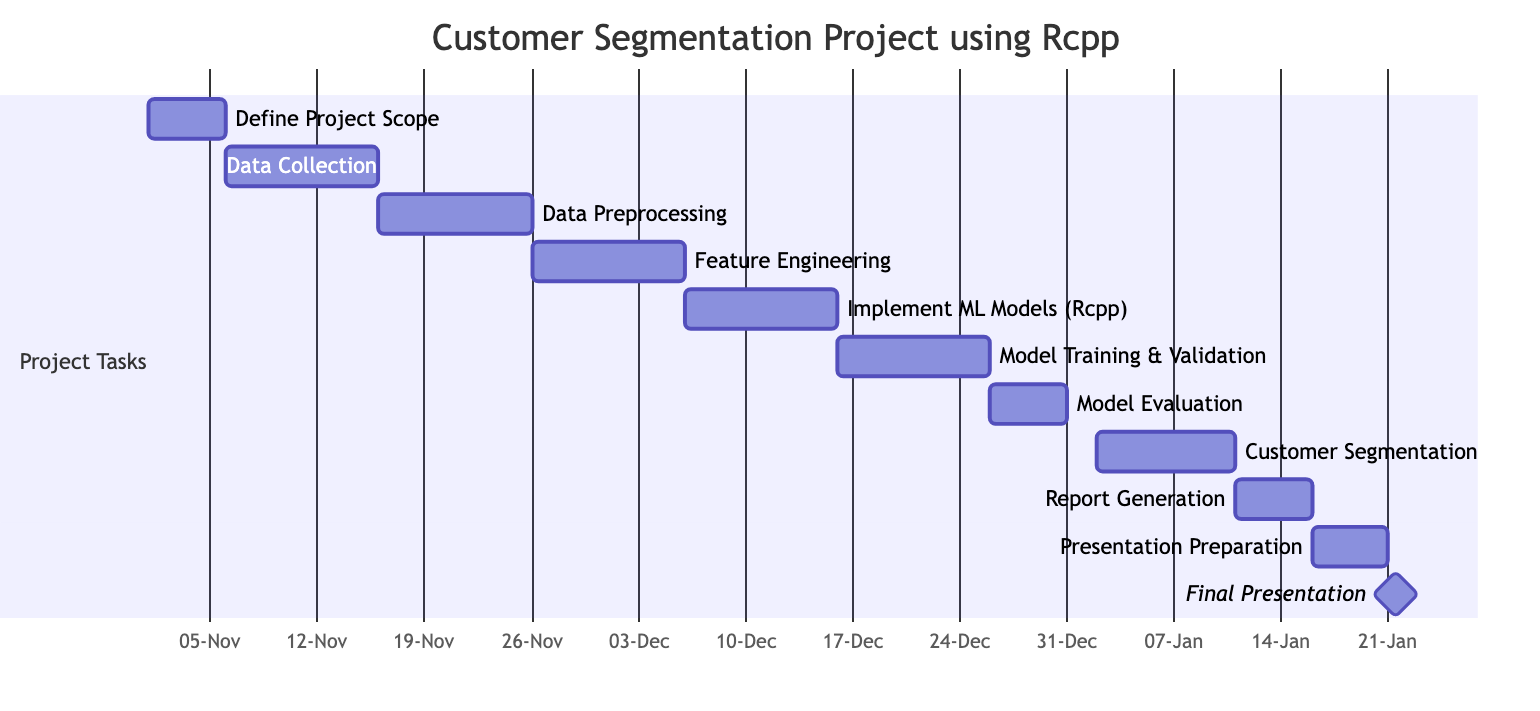What is the duration of the "Define Project Scope" activity? The "Define Project Scope" activity starts on November 1, 2023, and ends on November 5, 2023. This indicates that it lasts for 5 days.
Answer: 5 days Which activity follows "Data Collection"? According to the diagram, the activity that follows "Data Collection" is "Data Preprocessing." This can be seen clearly as "Data Preprocessing" is scheduled to start after "Data Collection" ends.
Answer: Data Preprocessing How many total activities are planned in the project? By counting each activity listed in the diagram, we find there are 11 activities in total (including all tasks from "Define Project Scope" to "Final Presentation").
Answer: 11 What is the end date of the "Customer Segmentation Analysis" activity? The "Customer Segmentation Analysis" activity is scheduled to end on January 10, 2024. This is directly stated in the diagram.
Answer: January 10, 2024 Which task is a prerequisite for "Model Evaluation"? The diagram indicates that "Model Training and Validation" must be completed before "Model Evaluation" can begin, as it's a dependency shown in the task sequence.
Answer: Model Training and Validation What is the total number of days allocated for the "Model Training and Validation" task? The "Model Training and Validation" activity starts on December 16, 2023, and ends on December 25, 2023. This equals 10 days of allocated time for this task.
Answer: 10 days On what date is the "Final Presentation" scheduled? The diagram specifies that the "Final Presentation" is a milestone that occurs on January 21, 2024. This is explicitly mentioned in the task timeline.
Answer: January 21, 2024 Which activity has the longest duration in the project timeline? By examining the durations of all activities, "Data Collection" and "Model Training and Validation" both last for 10 days each, but the longest continuous activity that is clearly stated is tied to "Feature Engineering," which is also 10 days.
Answer: 10 days When does the "Report Generation" task start? The "Report Generation" task begins after the "Customer Segmentation Analysis" has been completed, starting on January 11, 2024. This is shown as dependent on the previous task.
Answer: January 11, 2024 